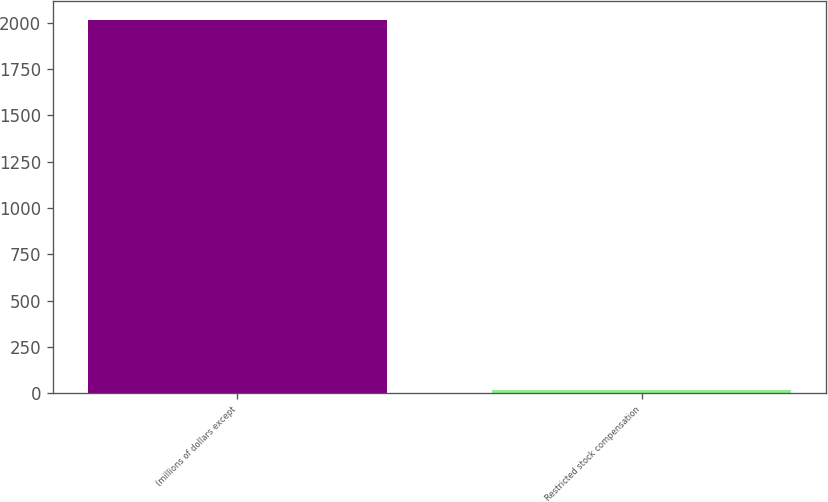<chart> <loc_0><loc_0><loc_500><loc_500><bar_chart><fcel>(millions of dollars except<fcel>Restricted stock compensation<nl><fcel>2017<fcel>19.7<nl></chart> 